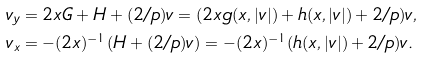Convert formula to latex. <formula><loc_0><loc_0><loc_500><loc_500>& v _ { y } = 2 x G + H + ( 2 / p ) v = ( 2 x g ( x , | v | ) + h ( x , | v | ) + 2 / p ) v , \\ & v _ { x } = - ( 2 x ) ^ { - 1 } ( H + ( 2 / p ) v ) = - ( 2 x ) ^ { - 1 } ( h ( x , | v | ) + 2 / p ) v .</formula> 